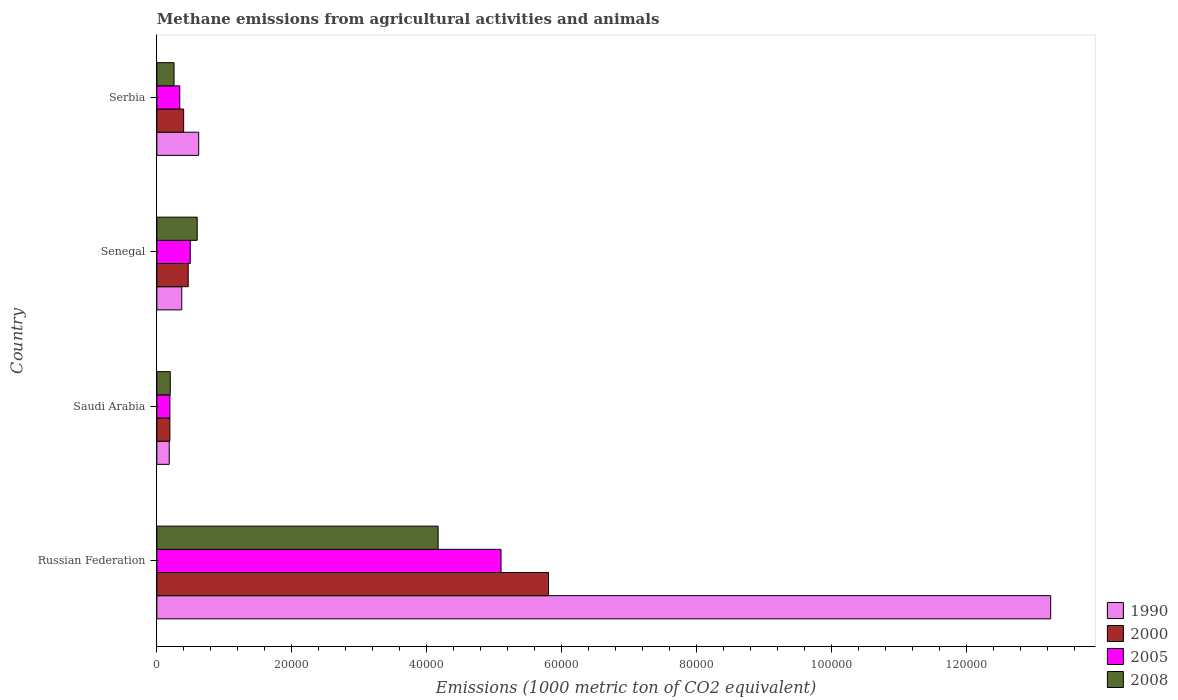Are the number of bars per tick equal to the number of legend labels?
Make the answer very short. Yes. Are the number of bars on each tick of the Y-axis equal?
Provide a succinct answer. Yes. What is the label of the 1st group of bars from the top?
Your answer should be compact. Serbia. What is the amount of methane emitted in 2008 in Saudi Arabia?
Your answer should be compact. 1991.7. Across all countries, what is the maximum amount of methane emitted in 1990?
Your answer should be very brief. 1.33e+05. Across all countries, what is the minimum amount of methane emitted in 2005?
Provide a succinct answer. 1933.6. In which country was the amount of methane emitted in 2005 maximum?
Your response must be concise. Russian Federation. In which country was the amount of methane emitted in 2005 minimum?
Offer a terse response. Saudi Arabia. What is the total amount of methane emitted in 2000 in the graph?
Offer a terse response. 6.86e+04. What is the difference between the amount of methane emitted in 2000 in Senegal and that in Serbia?
Give a very brief answer. 675.4. What is the difference between the amount of methane emitted in 2008 in Russian Federation and the amount of methane emitted in 2000 in Saudi Arabia?
Make the answer very short. 3.98e+04. What is the average amount of methane emitted in 2000 per country?
Your answer should be compact. 1.72e+04. What is the difference between the amount of methane emitted in 2008 and amount of methane emitted in 2005 in Russian Federation?
Make the answer very short. -9324.6. What is the ratio of the amount of methane emitted in 2000 in Senegal to that in Serbia?
Your answer should be very brief. 1.17. Is the difference between the amount of methane emitted in 2008 in Russian Federation and Saudi Arabia greater than the difference between the amount of methane emitted in 2005 in Russian Federation and Saudi Arabia?
Provide a succinct answer. No. What is the difference between the highest and the second highest amount of methane emitted in 2000?
Offer a very short reply. 5.34e+04. What is the difference between the highest and the lowest amount of methane emitted in 2008?
Keep it short and to the point. 3.97e+04. In how many countries, is the amount of methane emitted in 2005 greater than the average amount of methane emitted in 2005 taken over all countries?
Your answer should be compact. 1. Is the sum of the amount of methane emitted in 1990 in Senegal and Serbia greater than the maximum amount of methane emitted in 2005 across all countries?
Make the answer very short. No. What does the 1st bar from the bottom in Serbia represents?
Give a very brief answer. 1990. Is it the case that in every country, the sum of the amount of methane emitted in 2008 and amount of methane emitted in 1990 is greater than the amount of methane emitted in 2005?
Your response must be concise. Yes. Are all the bars in the graph horizontal?
Give a very brief answer. Yes. What is the difference between two consecutive major ticks on the X-axis?
Offer a very short reply. 2.00e+04. How many legend labels are there?
Provide a short and direct response. 4. What is the title of the graph?
Your answer should be very brief. Methane emissions from agricultural activities and animals. What is the label or title of the X-axis?
Your answer should be very brief. Emissions (1000 metric ton of CO2 equivalent). What is the Emissions (1000 metric ton of CO2 equivalent) in 1990 in Russian Federation?
Your response must be concise. 1.33e+05. What is the Emissions (1000 metric ton of CO2 equivalent) of 2000 in Russian Federation?
Offer a terse response. 5.81e+04. What is the Emissions (1000 metric ton of CO2 equivalent) of 2005 in Russian Federation?
Make the answer very short. 5.10e+04. What is the Emissions (1000 metric ton of CO2 equivalent) in 2008 in Russian Federation?
Keep it short and to the point. 4.17e+04. What is the Emissions (1000 metric ton of CO2 equivalent) of 1990 in Saudi Arabia?
Make the answer very short. 1840.2. What is the Emissions (1000 metric ton of CO2 equivalent) of 2000 in Saudi Arabia?
Your answer should be compact. 1928.5. What is the Emissions (1000 metric ton of CO2 equivalent) in 2005 in Saudi Arabia?
Keep it short and to the point. 1933.6. What is the Emissions (1000 metric ton of CO2 equivalent) in 2008 in Saudi Arabia?
Your response must be concise. 1991.7. What is the Emissions (1000 metric ton of CO2 equivalent) of 1990 in Senegal?
Your answer should be compact. 3695.6. What is the Emissions (1000 metric ton of CO2 equivalent) in 2000 in Senegal?
Provide a short and direct response. 4650.7. What is the Emissions (1000 metric ton of CO2 equivalent) in 2005 in Senegal?
Provide a succinct answer. 4955.1. What is the Emissions (1000 metric ton of CO2 equivalent) in 2008 in Senegal?
Your answer should be very brief. 5984.9. What is the Emissions (1000 metric ton of CO2 equivalent) of 1990 in Serbia?
Provide a succinct answer. 6208.8. What is the Emissions (1000 metric ton of CO2 equivalent) in 2000 in Serbia?
Make the answer very short. 3975.3. What is the Emissions (1000 metric ton of CO2 equivalent) in 2005 in Serbia?
Make the answer very short. 3399.6. What is the Emissions (1000 metric ton of CO2 equivalent) of 2008 in Serbia?
Your answer should be very brief. 2550.7. Across all countries, what is the maximum Emissions (1000 metric ton of CO2 equivalent) in 1990?
Ensure brevity in your answer.  1.33e+05. Across all countries, what is the maximum Emissions (1000 metric ton of CO2 equivalent) of 2000?
Make the answer very short. 5.81e+04. Across all countries, what is the maximum Emissions (1000 metric ton of CO2 equivalent) of 2005?
Provide a short and direct response. 5.10e+04. Across all countries, what is the maximum Emissions (1000 metric ton of CO2 equivalent) of 2008?
Keep it short and to the point. 4.17e+04. Across all countries, what is the minimum Emissions (1000 metric ton of CO2 equivalent) of 1990?
Your answer should be very brief. 1840.2. Across all countries, what is the minimum Emissions (1000 metric ton of CO2 equivalent) in 2000?
Your answer should be compact. 1928.5. Across all countries, what is the minimum Emissions (1000 metric ton of CO2 equivalent) of 2005?
Your response must be concise. 1933.6. Across all countries, what is the minimum Emissions (1000 metric ton of CO2 equivalent) in 2008?
Make the answer very short. 1991.7. What is the total Emissions (1000 metric ton of CO2 equivalent) of 1990 in the graph?
Provide a succinct answer. 1.44e+05. What is the total Emissions (1000 metric ton of CO2 equivalent) in 2000 in the graph?
Keep it short and to the point. 6.86e+04. What is the total Emissions (1000 metric ton of CO2 equivalent) in 2005 in the graph?
Your response must be concise. 6.13e+04. What is the total Emissions (1000 metric ton of CO2 equivalent) in 2008 in the graph?
Offer a very short reply. 5.22e+04. What is the difference between the Emissions (1000 metric ton of CO2 equivalent) in 1990 in Russian Federation and that in Saudi Arabia?
Your answer should be compact. 1.31e+05. What is the difference between the Emissions (1000 metric ton of CO2 equivalent) of 2000 in Russian Federation and that in Saudi Arabia?
Offer a very short reply. 5.61e+04. What is the difference between the Emissions (1000 metric ton of CO2 equivalent) in 2005 in Russian Federation and that in Saudi Arabia?
Keep it short and to the point. 4.91e+04. What is the difference between the Emissions (1000 metric ton of CO2 equivalent) in 2008 in Russian Federation and that in Saudi Arabia?
Your answer should be very brief. 3.97e+04. What is the difference between the Emissions (1000 metric ton of CO2 equivalent) in 1990 in Russian Federation and that in Senegal?
Make the answer very short. 1.29e+05. What is the difference between the Emissions (1000 metric ton of CO2 equivalent) in 2000 in Russian Federation and that in Senegal?
Offer a very short reply. 5.34e+04. What is the difference between the Emissions (1000 metric ton of CO2 equivalent) in 2005 in Russian Federation and that in Senegal?
Your response must be concise. 4.61e+04. What is the difference between the Emissions (1000 metric ton of CO2 equivalent) of 2008 in Russian Federation and that in Senegal?
Your answer should be compact. 3.57e+04. What is the difference between the Emissions (1000 metric ton of CO2 equivalent) of 1990 in Russian Federation and that in Serbia?
Keep it short and to the point. 1.26e+05. What is the difference between the Emissions (1000 metric ton of CO2 equivalent) of 2000 in Russian Federation and that in Serbia?
Your response must be concise. 5.41e+04. What is the difference between the Emissions (1000 metric ton of CO2 equivalent) of 2005 in Russian Federation and that in Serbia?
Your answer should be compact. 4.76e+04. What is the difference between the Emissions (1000 metric ton of CO2 equivalent) of 2008 in Russian Federation and that in Serbia?
Offer a very short reply. 3.92e+04. What is the difference between the Emissions (1000 metric ton of CO2 equivalent) of 1990 in Saudi Arabia and that in Senegal?
Ensure brevity in your answer.  -1855.4. What is the difference between the Emissions (1000 metric ton of CO2 equivalent) in 2000 in Saudi Arabia and that in Senegal?
Give a very brief answer. -2722.2. What is the difference between the Emissions (1000 metric ton of CO2 equivalent) in 2005 in Saudi Arabia and that in Senegal?
Offer a very short reply. -3021.5. What is the difference between the Emissions (1000 metric ton of CO2 equivalent) in 2008 in Saudi Arabia and that in Senegal?
Your answer should be very brief. -3993.2. What is the difference between the Emissions (1000 metric ton of CO2 equivalent) of 1990 in Saudi Arabia and that in Serbia?
Your answer should be very brief. -4368.6. What is the difference between the Emissions (1000 metric ton of CO2 equivalent) in 2000 in Saudi Arabia and that in Serbia?
Your response must be concise. -2046.8. What is the difference between the Emissions (1000 metric ton of CO2 equivalent) in 2005 in Saudi Arabia and that in Serbia?
Provide a succinct answer. -1466. What is the difference between the Emissions (1000 metric ton of CO2 equivalent) of 2008 in Saudi Arabia and that in Serbia?
Your answer should be very brief. -559. What is the difference between the Emissions (1000 metric ton of CO2 equivalent) in 1990 in Senegal and that in Serbia?
Your answer should be compact. -2513.2. What is the difference between the Emissions (1000 metric ton of CO2 equivalent) in 2000 in Senegal and that in Serbia?
Make the answer very short. 675.4. What is the difference between the Emissions (1000 metric ton of CO2 equivalent) in 2005 in Senegal and that in Serbia?
Keep it short and to the point. 1555.5. What is the difference between the Emissions (1000 metric ton of CO2 equivalent) of 2008 in Senegal and that in Serbia?
Your answer should be compact. 3434.2. What is the difference between the Emissions (1000 metric ton of CO2 equivalent) of 1990 in Russian Federation and the Emissions (1000 metric ton of CO2 equivalent) of 2000 in Saudi Arabia?
Provide a succinct answer. 1.31e+05. What is the difference between the Emissions (1000 metric ton of CO2 equivalent) in 1990 in Russian Federation and the Emissions (1000 metric ton of CO2 equivalent) in 2005 in Saudi Arabia?
Your answer should be compact. 1.31e+05. What is the difference between the Emissions (1000 metric ton of CO2 equivalent) of 1990 in Russian Federation and the Emissions (1000 metric ton of CO2 equivalent) of 2008 in Saudi Arabia?
Your answer should be very brief. 1.31e+05. What is the difference between the Emissions (1000 metric ton of CO2 equivalent) of 2000 in Russian Federation and the Emissions (1000 metric ton of CO2 equivalent) of 2005 in Saudi Arabia?
Offer a terse response. 5.61e+04. What is the difference between the Emissions (1000 metric ton of CO2 equivalent) in 2000 in Russian Federation and the Emissions (1000 metric ton of CO2 equivalent) in 2008 in Saudi Arabia?
Your response must be concise. 5.61e+04. What is the difference between the Emissions (1000 metric ton of CO2 equivalent) in 2005 in Russian Federation and the Emissions (1000 metric ton of CO2 equivalent) in 2008 in Saudi Arabia?
Ensure brevity in your answer.  4.90e+04. What is the difference between the Emissions (1000 metric ton of CO2 equivalent) of 1990 in Russian Federation and the Emissions (1000 metric ton of CO2 equivalent) of 2000 in Senegal?
Ensure brevity in your answer.  1.28e+05. What is the difference between the Emissions (1000 metric ton of CO2 equivalent) in 1990 in Russian Federation and the Emissions (1000 metric ton of CO2 equivalent) in 2005 in Senegal?
Offer a very short reply. 1.28e+05. What is the difference between the Emissions (1000 metric ton of CO2 equivalent) of 1990 in Russian Federation and the Emissions (1000 metric ton of CO2 equivalent) of 2008 in Senegal?
Make the answer very short. 1.27e+05. What is the difference between the Emissions (1000 metric ton of CO2 equivalent) in 2000 in Russian Federation and the Emissions (1000 metric ton of CO2 equivalent) in 2005 in Senegal?
Give a very brief answer. 5.31e+04. What is the difference between the Emissions (1000 metric ton of CO2 equivalent) of 2000 in Russian Federation and the Emissions (1000 metric ton of CO2 equivalent) of 2008 in Senegal?
Your response must be concise. 5.21e+04. What is the difference between the Emissions (1000 metric ton of CO2 equivalent) in 2005 in Russian Federation and the Emissions (1000 metric ton of CO2 equivalent) in 2008 in Senegal?
Keep it short and to the point. 4.51e+04. What is the difference between the Emissions (1000 metric ton of CO2 equivalent) of 1990 in Russian Federation and the Emissions (1000 metric ton of CO2 equivalent) of 2000 in Serbia?
Give a very brief answer. 1.29e+05. What is the difference between the Emissions (1000 metric ton of CO2 equivalent) of 1990 in Russian Federation and the Emissions (1000 metric ton of CO2 equivalent) of 2005 in Serbia?
Your answer should be very brief. 1.29e+05. What is the difference between the Emissions (1000 metric ton of CO2 equivalent) of 1990 in Russian Federation and the Emissions (1000 metric ton of CO2 equivalent) of 2008 in Serbia?
Make the answer very short. 1.30e+05. What is the difference between the Emissions (1000 metric ton of CO2 equivalent) of 2000 in Russian Federation and the Emissions (1000 metric ton of CO2 equivalent) of 2005 in Serbia?
Offer a terse response. 5.47e+04. What is the difference between the Emissions (1000 metric ton of CO2 equivalent) in 2000 in Russian Federation and the Emissions (1000 metric ton of CO2 equivalent) in 2008 in Serbia?
Give a very brief answer. 5.55e+04. What is the difference between the Emissions (1000 metric ton of CO2 equivalent) in 2005 in Russian Federation and the Emissions (1000 metric ton of CO2 equivalent) in 2008 in Serbia?
Your answer should be very brief. 4.85e+04. What is the difference between the Emissions (1000 metric ton of CO2 equivalent) of 1990 in Saudi Arabia and the Emissions (1000 metric ton of CO2 equivalent) of 2000 in Senegal?
Your answer should be compact. -2810.5. What is the difference between the Emissions (1000 metric ton of CO2 equivalent) of 1990 in Saudi Arabia and the Emissions (1000 metric ton of CO2 equivalent) of 2005 in Senegal?
Make the answer very short. -3114.9. What is the difference between the Emissions (1000 metric ton of CO2 equivalent) in 1990 in Saudi Arabia and the Emissions (1000 metric ton of CO2 equivalent) in 2008 in Senegal?
Make the answer very short. -4144.7. What is the difference between the Emissions (1000 metric ton of CO2 equivalent) of 2000 in Saudi Arabia and the Emissions (1000 metric ton of CO2 equivalent) of 2005 in Senegal?
Provide a succinct answer. -3026.6. What is the difference between the Emissions (1000 metric ton of CO2 equivalent) of 2000 in Saudi Arabia and the Emissions (1000 metric ton of CO2 equivalent) of 2008 in Senegal?
Your response must be concise. -4056.4. What is the difference between the Emissions (1000 metric ton of CO2 equivalent) in 2005 in Saudi Arabia and the Emissions (1000 metric ton of CO2 equivalent) in 2008 in Senegal?
Give a very brief answer. -4051.3. What is the difference between the Emissions (1000 metric ton of CO2 equivalent) of 1990 in Saudi Arabia and the Emissions (1000 metric ton of CO2 equivalent) of 2000 in Serbia?
Your answer should be very brief. -2135.1. What is the difference between the Emissions (1000 metric ton of CO2 equivalent) in 1990 in Saudi Arabia and the Emissions (1000 metric ton of CO2 equivalent) in 2005 in Serbia?
Ensure brevity in your answer.  -1559.4. What is the difference between the Emissions (1000 metric ton of CO2 equivalent) in 1990 in Saudi Arabia and the Emissions (1000 metric ton of CO2 equivalent) in 2008 in Serbia?
Your response must be concise. -710.5. What is the difference between the Emissions (1000 metric ton of CO2 equivalent) of 2000 in Saudi Arabia and the Emissions (1000 metric ton of CO2 equivalent) of 2005 in Serbia?
Provide a succinct answer. -1471.1. What is the difference between the Emissions (1000 metric ton of CO2 equivalent) of 2000 in Saudi Arabia and the Emissions (1000 metric ton of CO2 equivalent) of 2008 in Serbia?
Keep it short and to the point. -622.2. What is the difference between the Emissions (1000 metric ton of CO2 equivalent) in 2005 in Saudi Arabia and the Emissions (1000 metric ton of CO2 equivalent) in 2008 in Serbia?
Your response must be concise. -617.1. What is the difference between the Emissions (1000 metric ton of CO2 equivalent) in 1990 in Senegal and the Emissions (1000 metric ton of CO2 equivalent) in 2000 in Serbia?
Provide a succinct answer. -279.7. What is the difference between the Emissions (1000 metric ton of CO2 equivalent) of 1990 in Senegal and the Emissions (1000 metric ton of CO2 equivalent) of 2005 in Serbia?
Your answer should be very brief. 296. What is the difference between the Emissions (1000 metric ton of CO2 equivalent) in 1990 in Senegal and the Emissions (1000 metric ton of CO2 equivalent) in 2008 in Serbia?
Provide a short and direct response. 1144.9. What is the difference between the Emissions (1000 metric ton of CO2 equivalent) in 2000 in Senegal and the Emissions (1000 metric ton of CO2 equivalent) in 2005 in Serbia?
Offer a terse response. 1251.1. What is the difference between the Emissions (1000 metric ton of CO2 equivalent) of 2000 in Senegal and the Emissions (1000 metric ton of CO2 equivalent) of 2008 in Serbia?
Offer a terse response. 2100. What is the difference between the Emissions (1000 metric ton of CO2 equivalent) in 2005 in Senegal and the Emissions (1000 metric ton of CO2 equivalent) in 2008 in Serbia?
Keep it short and to the point. 2404.4. What is the average Emissions (1000 metric ton of CO2 equivalent) in 1990 per country?
Make the answer very short. 3.61e+04. What is the average Emissions (1000 metric ton of CO2 equivalent) in 2000 per country?
Provide a short and direct response. 1.72e+04. What is the average Emissions (1000 metric ton of CO2 equivalent) of 2005 per country?
Make the answer very short. 1.53e+04. What is the average Emissions (1000 metric ton of CO2 equivalent) of 2008 per country?
Provide a succinct answer. 1.31e+04. What is the difference between the Emissions (1000 metric ton of CO2 equivalent) of 1990 and Emissions (1000 metric ton of CO2 equivalent) of 2000 in Russian Federation?
Provide a succinct answer. 7.45e+04. What is the difference between the Emissions (1000 metric ton of CO2 equivalent) in 1990 and Emissions (1000 metric ton of CO2 equivalent) in 2005 in Russian Federation?
Give a very brief answer. 8.15e+04. What is the difference between the Emissions (1000 metric ton of CO2 equivalent) of 1990 and Emissions (1000 metric ton of CO2 equivalent) of 2008 in Russian Federation?
Offer a terse response. 9.08e+04. What is the difference between the Emissions (1000 metric ton of CO2 equivalent) in 2000 and Emissions (1000 metric ton of CO2 equivalent) in 2005 in Russian Federation?
Your answer should be compact. 7040. What is the difference between the Emissions (1000 metric ton of CO2 equivalent) in 2000 and Emissions (1000 metric ton of CO2 equivalent) in 2008 in Russian Federation?
Give a very brief answer. 1.64e+04. What is the difference between the Emissions (1000 metric ton of CO2 equivalent) in 2005 and Emissions (1000 metric ton of CO2 equivalent) in 2008 in Russian Federation?
Your response must be concise. 9324.6. What is the difference between the Emissions (1000 metric ton of CO2 equivalent) in 1990 and Emissions (1000 metric ton of CO2 equivalent) in 2000 in Saudi Arabia?
Offer a terse response. -88.3. What is the difference between the Emissions (1000 metric ton of CO2 equivalent) in 1990 and Emissions (1000 metric ton of CO2 equivalent) in 2005 in Saudi Arabia?
Your answer should be very brief. -93.4. What is the difference between the Emissions (1000 metric ton of CO2 equivalent) of 1990 and Emissions (1000 metric ton of CO2 equivalent) of 2008 in Saudi Arabia?
Offer a terse response. -151.5. What is the difference between the Emissions (1000 metric ton of CO2 equivalent) in 2000 and Emissions (1000 metric ton of CO2 equivalent) in 2005 in Saudi Arabia?
Provide a short and direct response. -5.1. What is the difference between the Emissions (1000 metric ton of CO2 equivalent) of 2000 and Emissions (1000 metric ton of CO2 equivalent) of 2008 in Saudi Arabia?
Offer a terse response. -63.2. What is the difference between the Emissions (1000 metric ton of CO2 equivalent) in 2005 and Emissions (1000 metric ton of CO2 equivalent) in 2008 in Saudi Arabia?
Make the answer very short. -58.1. What is the difference between the Emissions (1000 metric ton of CO2 equivalent) of 1990 and Emissions (1000 metric ton of CO2 equivalent) of 2000 in Senegal?
Your answer should be compact. -955.1. What is the difference between the Emissions (1000 metric ton of CO2 equivalent) of 1990 and Emissions (1000 metric ton of CO2 equivalent) of 2005 in Senegal?
Give a very brief answer. -1259.5. What is the difference between the Emissions (1000 metric ton of CO2 equivalent) of 1990 and Emissions (1000 metric ton of CO2 equivalent) of 2008 in Senegal?
Your response must be concise. -2289.3. What is the difference between the Emissions (1000 metric ton of CO2 equivalent) of 2000 and Emissions (1000 metric ton of CO2 equivalent) of 2005 in Senegal?
Ensure brevity in your answer.  -304.4. What is the difference between the Emissions (1000 metric ton of CO2 equivalent) in 2000 and Emissions (1000 metric ton of CO2 equivalent) in 2008 in Senegal?
Give a very brief answer. -1334.2. What is the difference between the Emissions (1000 metric ton of CO2 equivalent) in 2005 and Emissions (1000 metric ton of CO2 equivalent) in 2008 in Senegal?
Provide a short and direct response. -1029.8. What is the difference between the Emissions (1000 metric ton of CO2 equivalent) of 1990 and Emissions (1000 metric ton of CO2 equivalent) of 2000 in Serbia?
Provide a succinct answer. 2233.5. What is the difference between the Emissions (1000 metric ton of CO2 equivalent) in 1990 and Emissions (1000 metric ton of CO2 equivalent) in 2005 in Serbia?
Make the answer very short. 2809.2. What is the difference between the Emissions (1000 metric ton of CO2 equivalent) of 1990 and Emissions (1000 metric ton of CO2 equivalent) of 2008 in Serbia?
Your answer should be very brief. 3658.1. What is the difference between the Emissions (1000 metric ton of CO2 equivalent) in 2000 and Emissions (1000 metric ton of CO2 equivalent) in 2005 in Serbia?
Provide a short and direct response. 575.7. What is the difference between the Emissions (1000 metric ton of CO2 equivalent) of 2000 and Emissions (1000 metric ton of CO2 equivalent) of 2008 in Serbia?
Your answer should be very brief. 1424.6. What is the difference between the Emissions (1000 metric ton of CO2 equivalent) in 2005 and Emissions (1000 metric ton of CO2 equivalent) in 2008 in Serbia?
Provide a succinct answer. 848.9. What is the ratio of the Emissions (1000 metric ton of CO2 equivalent) of 1990 in Russian Federation to that in Saudi Arabia?
Offer a terse response. 72.03. What is the ratio of the Emissions (1000 metric ton of CO2 equivalent) in 2000 in Russian Federation to that in Saudi Arabia?
Offer a terse response. 30.11. What is the ratio of the Emissions (1000 metric ton of CO2 equivalent) in 2005 in Russian Federation to that in Saudi Arabia?
Keep it short and to the point. 26.39. What is the ratio of the Emissions (1000 metric ton of CO2 equivalent) of 2008 in Russian Federation to that in Saudi Arabia?
Make the answer very short. 20.94. What is the ratio of the Emissions (1000 metric ton of CO2 equivalent) of 1990 in Russian Federation to that in Senegal?
Keep it short and to the point. 35.86. What is the ratio of the Emissions (1000 metric ton of CO2 equivalent) of 2000 in Russian Federation to that in Senegal?
Your answer should be very brief. 12.49. What is the ratio of the Emissions (1000 metric ton of CO2 equivalent) in 2005 in Russian Federation to that in Senegal?
Provide a short and direct response. 10.3. What is the ratio of the Emissions (1000 metric ton of CO2 equivalent) in 2008 in Russian Federation to that in Senegal?
Provide a succinct answer. 6.97. What is the ratio of the Emissions (1000 metric ton of CO2 equivalent) of 1990 in Russian Federation to that in Serbia?
Make the answer very short. 21.35. What is the ratio of the Emissions (1000 metric ton of CO2 equivalent) in 2000 in Russian Federation to that in Serbia?
Your answer should be very brief. 14.61. What is the ratio of the Emissions (1000 metric ton of CO2 equivalent) in 2005 in Russian Federation to that in Serbia?
Your response must be concise. 15.01. What is the ratio of the Emissions (1000 metric ton of CO2 equivalent) in 2008 in Russian Federation to that in Serbia?
Your response must be concise. 16.35. What is the ratio of the Emissions (1000 metric ton of CO2 equivalent) in 1990 in Saudi Arabia to that in Senegal?
Keep it short and to the point. 0.5. What is the ratio of the Emissions (1000 metric ton of CO2 equivalent) in 2000 in Saudi Arabia to that in Senegal?
Your answer should be very brief. 0.41. What is the ratio of the Emissions (1000 metric ton of CO2 equivalent) of 2005 in Saudi Arabia to that in Senegal?
Offer a terse response. 0.39. What is the ratio of the Emissions (1000 metric ton of CO2 equivalent) in 2008 in Saudi Arabia to that in Senegal?
Offer a terse response. 0.33. What is the ratio of the Emissions (1000 metric ton of CO2 equivalent) in 1990 in Saudi Arabia to that in Serbia?
Your answer should be very brief. 0.3. What is the ratio of the Emissions (1000 metric ton of CO2 equivalent) in 2000 in Saudi Arabia to that in Serbia?
Offer a terse response. 0.49. What is the ratio of the Emissions (1000 metric ton of CO2 equivalent) of 2005 in Saudi Arabia to that in Serbia?
Provide a succinct answer. 0.57. What is the ratio of the Emissions (1000 metric ton of CO2 equivalent) in 2008 in Saudi Arabia to that in Serbia?
Provide a short and direct response. 0.78. What is the ratio of the Emissions (1000 metric ton of CO2 equivalent) of 1990 in Senegal to that in Serbia?
Provide a succinct answer. 0.6. What is the ratio of the Emissions (1000 metric ton of CO2 equivalent) in 2000 in Senegal to that in Serbia?
Ensure brevity in your answer.  1.17. What is the ratio of the Emissions (1000 metric ton of CO2 equivalent) in 2005 in Senegal to that in Serbia?
Your answer should be compact. 1.46. What is the ratio of the Emissions (1000 metric ton of CO2 equivalent) in 2008 in Senegal to that in Serbia?
Offer a very short reply. 2.35. What is the difference between the highest and the second highest Emissions (1000 metric ton of CO2 equivalent) of 1990?
Keep it short and to the point. 1.26e+05. What is the difference between the highest and the second highest Emissions (1000 metric ton of CO2 equivalent) of 2000?
Offer a terse response. 5.34e+04. What is the difference between the highest and the second highest Emissions (1000 metric ton of CO2 equivalent) in 2005?
Ensure brevity in your answer.  4.61e+04. What is the difference between the highest and the second highest Emissions (1000 metric ton of CO2 equivalent) in 2008?
Keep it short and to the point. 3.57e+04. What is the difference between the highest and the lowest Emissions (1000 metric ton of CO2 equivalent) of 1990?
Offer a terse response. 1.31e+05. What is the difference between the highest and the lowest Emissions (1000 metric ton of CO2 equivalent) in 2000?
Keep it short and to the point. 5.61e+04. What is the difference between the highest and the lowest Emissions (1000 metric ton of CO2 equivalent) in 2005?
Make the answer very short. 4.91e+04. What is the difference between the highest and the lowest Emissions (1000 metric ton of CO2 equivalent) in 2008?
Provide a short and direct response. 3.97e+04. 